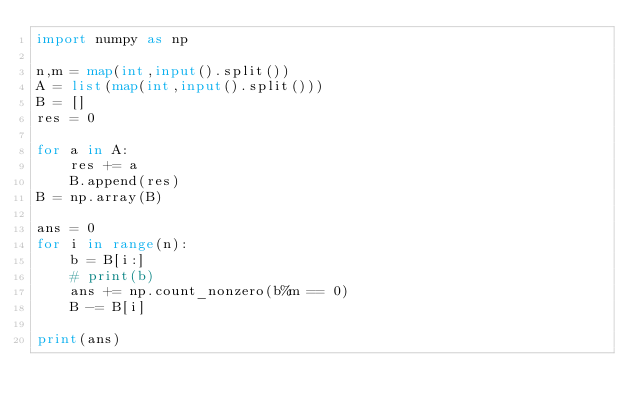<code> <loc_0><loc_0><loc_500><loc_500><_Python_>import numpy as np

n,m = map(int,input().split())
A = list(map(int,input().split()))
B = []
res = 0

for a in A:
    res += a
    B.append(res)
B = np.array(B)

ans = 0
for i in range(n):
    b = B[i:]
    # print(b)
    ans += np.count_nonzero(b%m == 0)
    B -= B[i]

print(ans)</code> 